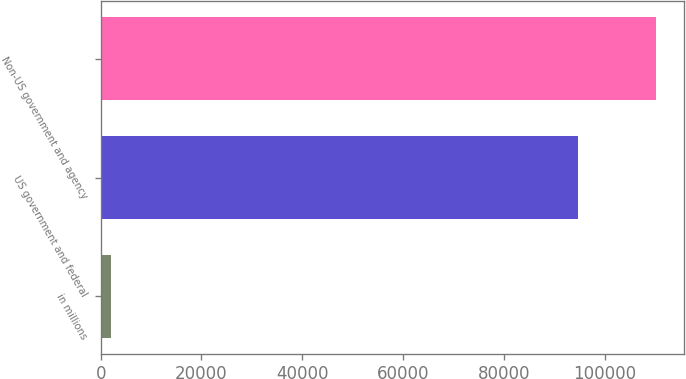Convert chart. <chart><loc_0><loc_0><loc_500><loc_500><bar_chart><fcel>in millions<fcel>US government and federal<fcel>Non-US government and agency<nl><fcel>2011<fcel>94603<fcel>110178<nl></chart> 